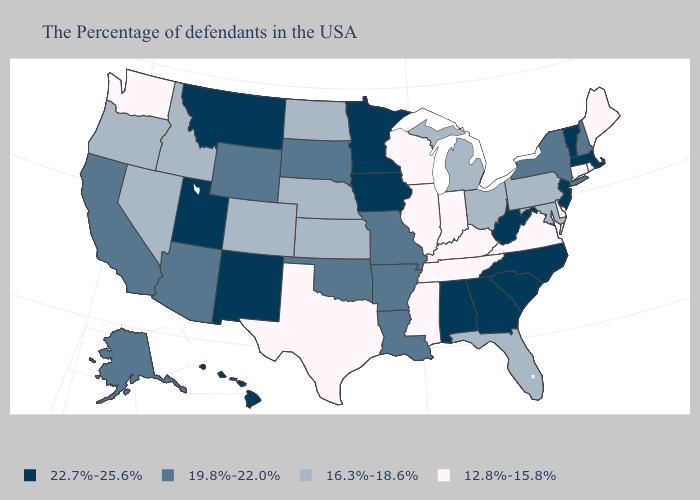Name the states that have a value in the range 16.3%-18.6%?
Short answer required. Maryland, Pennsylvania, Ohio, Florida, Michigan, Kansas, Nebraska, North Dakota, Colorado, Idaho, Nevada, Oregon. Does Minnesota have the same value as West Virginia?
Answer briefly. Yes. Does South Carolina have the highest value in the South?
Short answer required. Yes. Is the legend a continuous bar?
Short answer required. No. Does Pennsylvania have a higher value than Oklahoma?
Short answer required. No. Name the states that have a value in the range 19.8%-22.0%?
Concise answer only. New Hampshire, New York, Louisiana, Missouri, Arkansas, Oklahoma, South Dakota, Wyoming, Arizona, California, Alaska. Name the states that have a value in the range 12.8%-15.8%?
Short answer required. Maine, Rhode Island, Connecticut, Delaware, Virginia, Kentucky, Indiana, Tennessee, Wisconsin, Illinois, Mississippi, Texas, Washington. Name the states that have a value in the range 19.8%-22.0%?
Keep it brief. New Hampshire, New York, Louisiana, Missouri, Arkansas, Oklahoma, South Dakota, Wyoming, Arizona, California, Alaska. What is the value of Virginia?
Concise answer only. 12.8%-15.8%. What is the value of Tennessee?
Write a very short answer. 12.8%-15.8%. Does the map have missing data?
Keep it brief. No. Name the states that have a value in the range 22.7%-25.6%?
Concise answer only. Massachusetts, Vermont, New Jersey, North Carolina, South Carolina, West Virginia, Georgia, Alabama, Minnesota, Iowa, New Mexico, Utah, Montana, Hawaii. Does Washington have the lowest value in the USA?
Concise answer only. Yes. Name the states that have a value in the range 16.3%-18.6%?
Quick response, please. Maryland, Pennsylvania, Ohio, Florida, Michigan, Kansas, Nebraska, North Dakota, Colorado, Idaho, Nevada, Oregon. Name the states that have a value in the range 12.8%-15.8%?
Give a very brief answer. Maine, Rhode Island, Connecticut, Delaware, Virginia, Kentucky, Indiana, Tennessee, Wisconsin, Illinois, Mississippi, Texas, Washington. 